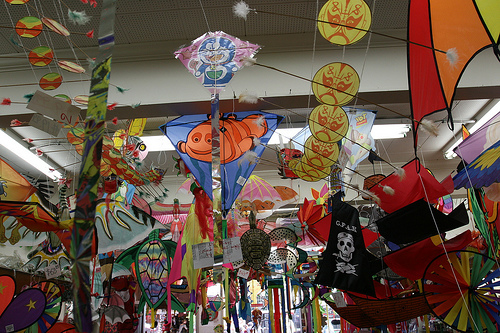<image>
Is there a kite under the ceiling? Yes. The kite is positioned underneath the ceiling, with the ceiling above it in the vertical space. Where is the kite in relation to the kite? Is it behind the kite? Yes. From this viewpoint, the kite is positioned behind the kite, with the kite partially or fully occluding the kite. 